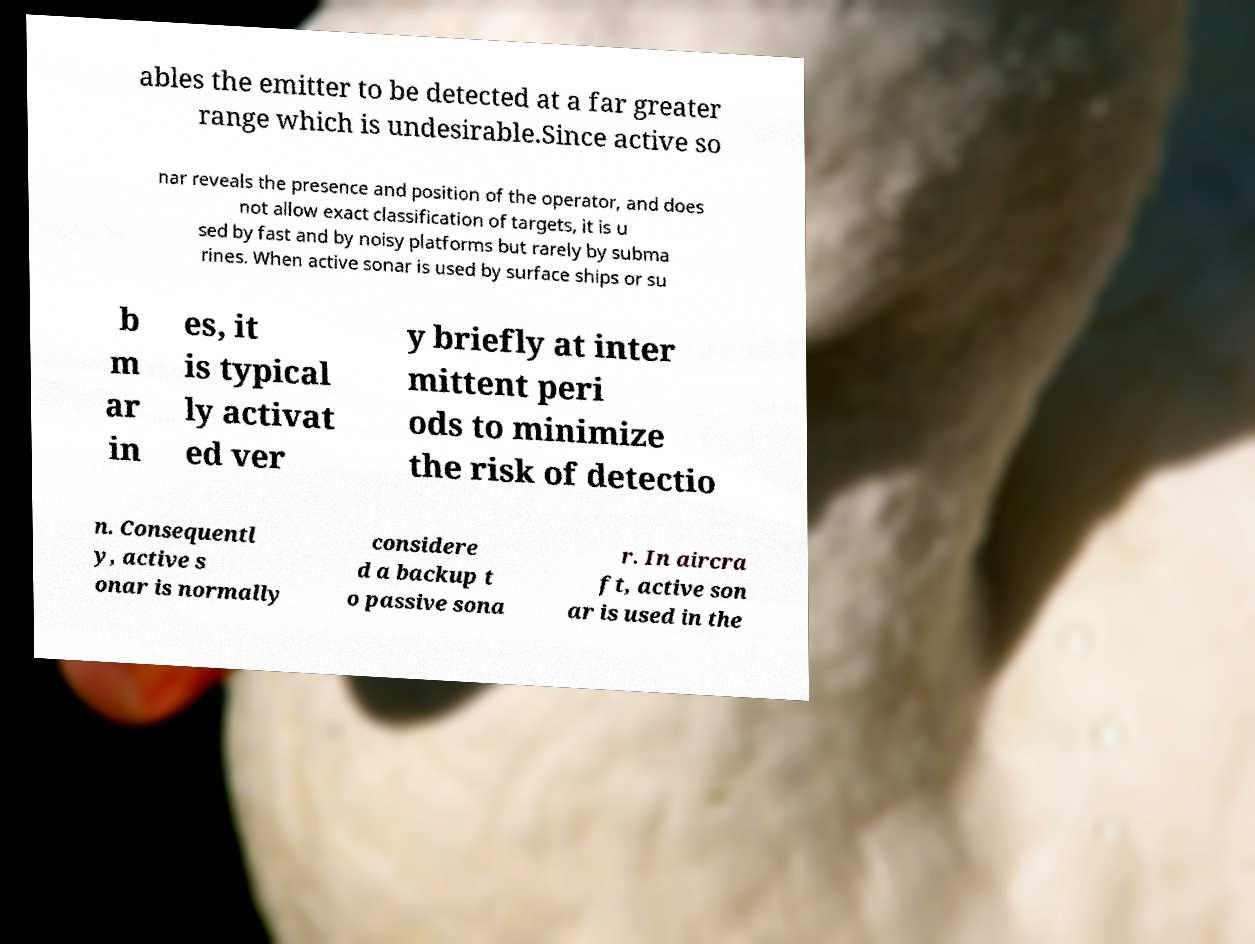Can you accurately transcribe the text from the provided image for me? ables the emitter to be detected at a far greater range which is undesirable.Since active so nar reveals the presence and position of the operator, and does not allow exact classification of targets, it is u sed by fast and by noisy platforms but rarely by subma rines. When active sonar is used by surface ships or su b m ar in es, it is typical ly activat ed ver y briefly at inter mittent peri ods to minimize the risk of detectio n. Consequentl y, active s onar is normally considere d a backup t o passive sona r. In aircra ft, active son ar is used in the 